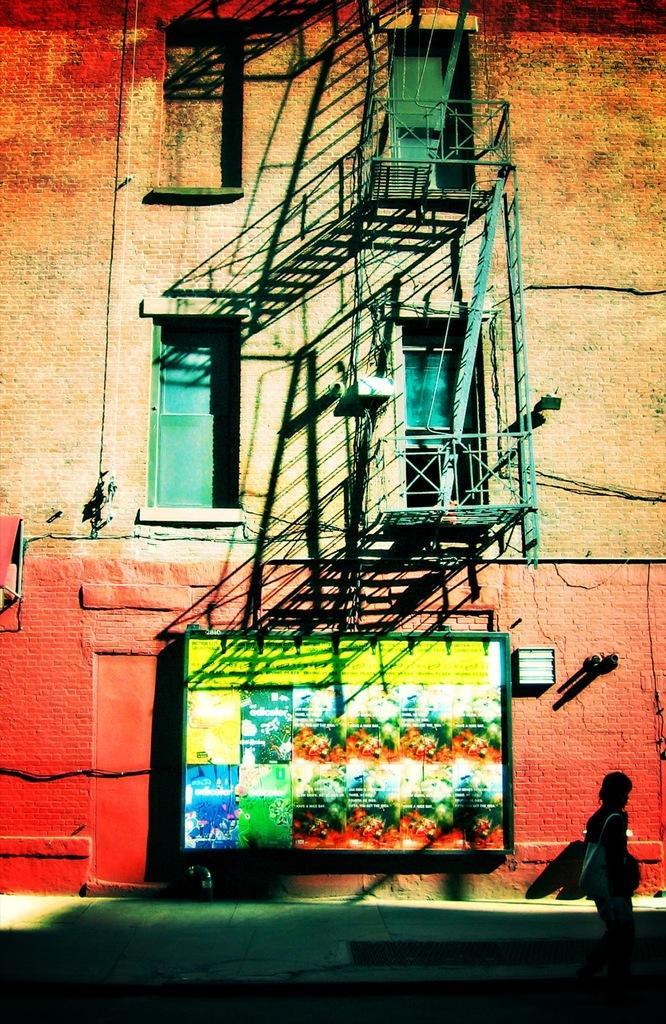In one or two sentences, can you explain what this image depicts? In this image we can see a woman wearing bag is walking on the ground. In the center of the image we can see a building with windows, railings, pipes and some ladders, we can also see a frame with pictures placed on the wall 